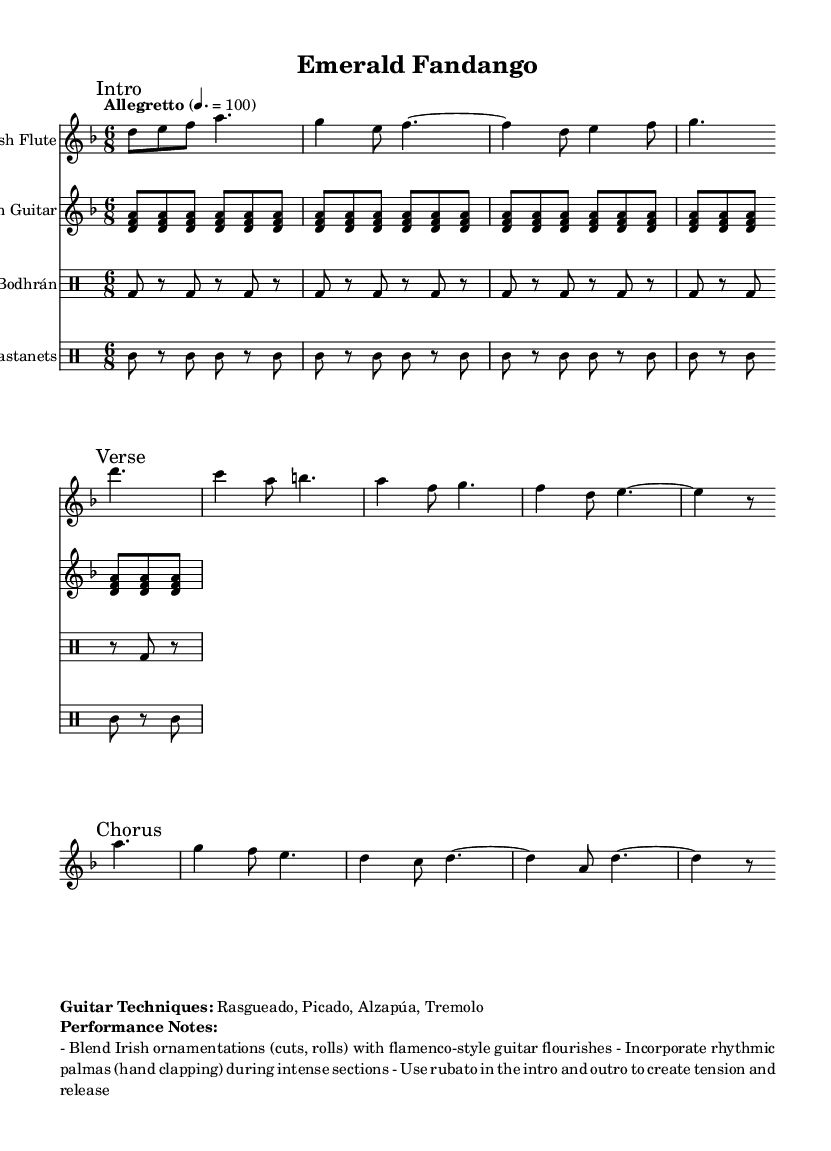What is the key signature of this music? The key signature is indicated at the beginning of the sheet music, showing two flats which correspond to the key of D minor.
Answer: D minor What is the time signature? The time signature is displayed prominently in the opening of the score, indicating a compound meter with six eighth notes per measure.
Answer: Six eighth What is the tempo marking for the piece? The tempo marking, found at the beginning of the score, indicates the speed at which the piece should be played, stated clearly as "Allegretto" with a metronome marking of 100.
Answer: Allegretto How many measures are in the intro section? By counting the measures from the beginning of the flute part until the first break, there are a total of four measures in the intro section.
Answer: Four measures What guitar techniques are used in the composition? The score explicitly lists the guitar techniques in the markup section under "Guitar Techniques," including rasgueado, picado, alzapúa, and tremolo.
Answer: Rasgueado, picado, alzapúa, tremolo Which instruments are included in this fusion piece? By observing the score, multiple staves are displayed, indicating the inclusion of an Irish flute, Spanish guitar, bodhrán, and castanets as the instruments used in the performance.
Answer: Irish flute, Spanish guitar, bodhrán, castanets What performance note suggests a rhythmic element during intense sections? The performance notes section recommends incorporating rhythmic elements, specifically palmas (hand clapping), during the intense sections to enhance the overall rhythm and energy.
Answer: Palmas 